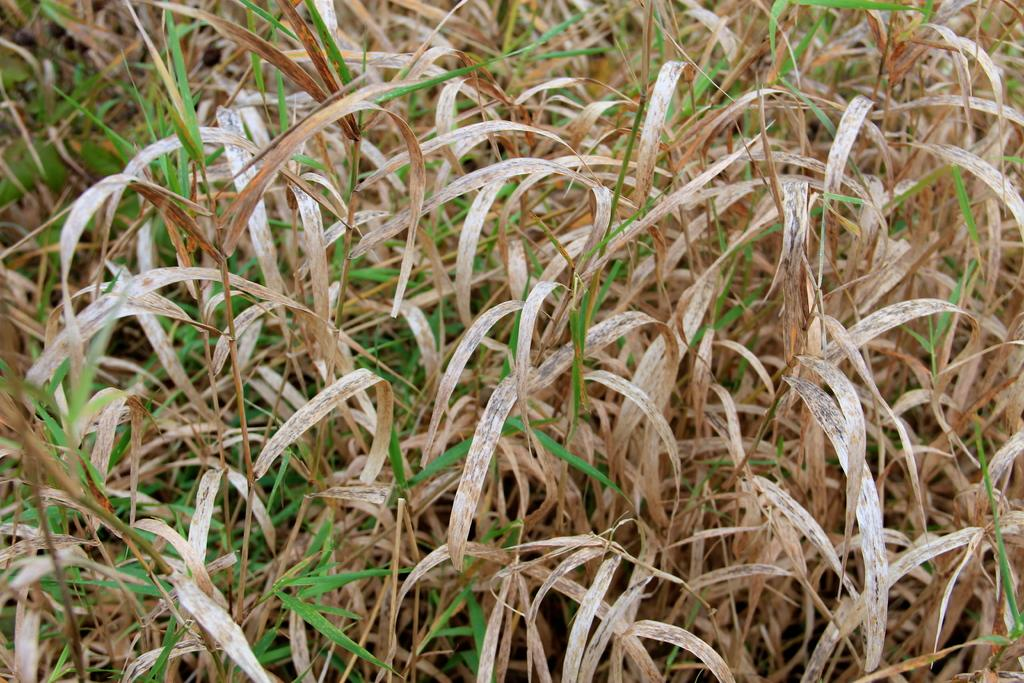What type of living organisms can be seen in the image? Plants can be seen in the image. Where was the image taken? The image was taken in a field. What type of iron is visible in the image? There is no iron present in the image; it features plants in a field. What body part can be seen interacting with the plants in the image? There are no body parts visible in the image, as it only shows plants in a field. 